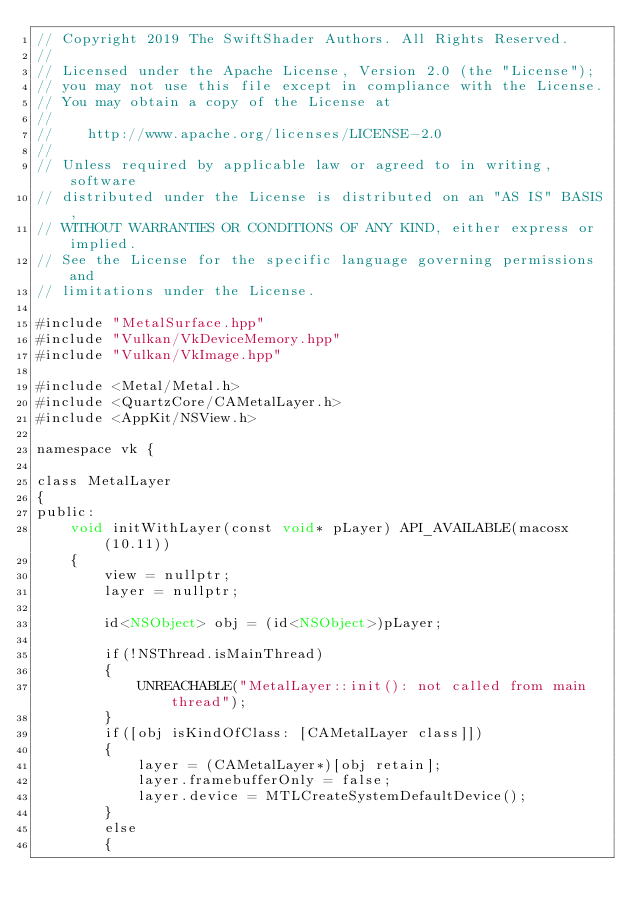<code> <loc_0><loc_0><loc_500><loc_500><_ObjectiveC_>// Copyright 2019 The SwiftShader Authors. All Rights Reserved.
//
// Licensed under the Apache License, Version 2.0 (the "License");
// you may not use this file except in compliance with the License.
// You may obtain a copy of the License at
//
//    http://www.apache.org/licenses/LICENSE-2.0
//
// Unless required by applicable law or agreed to in writing, software
// distributed under the License is distributed on an "AS IS" BASIS,
// WITHOUT WARRANTIES OR CONDITIONS OF ANY KIND, either express or implied.
// See the License for the specific language governing permissions and
// limitations under the License.

#include "MetalSurface.hpp"
#include "Vulkan/VkDeviceMemory.hpp"
#include "Vulkan/VkImage.hpp"

#include <Metal/Metal.h>
#include <QuartzCore/CAMetalLayer.h>
#include <AppKit/NSView.h>

namespace vk {

class MetalLayer
{
public:
    void initWithLayer(const void* pLayer) API_AVAILABLE(macosx(10.11))
    {
        view = nullptr;
        layer = nullptr;

        id<NSObject> obj = (id<NSObject>)pLayer;

        if(!NSThread.isMainThread)
        {
            UNREACHABLE("MetalLayer::init(): not called from main thread");
        }
        if([obj isKindOfClass: [CAMetalLayer class]])
        {
            layer = (CAMetalLayer*)[obj retain];
            layer.framebufferOnly = false;
            layer.device = MTLCreateSystemDefaultDevice();
        }
        else
        {</code> 